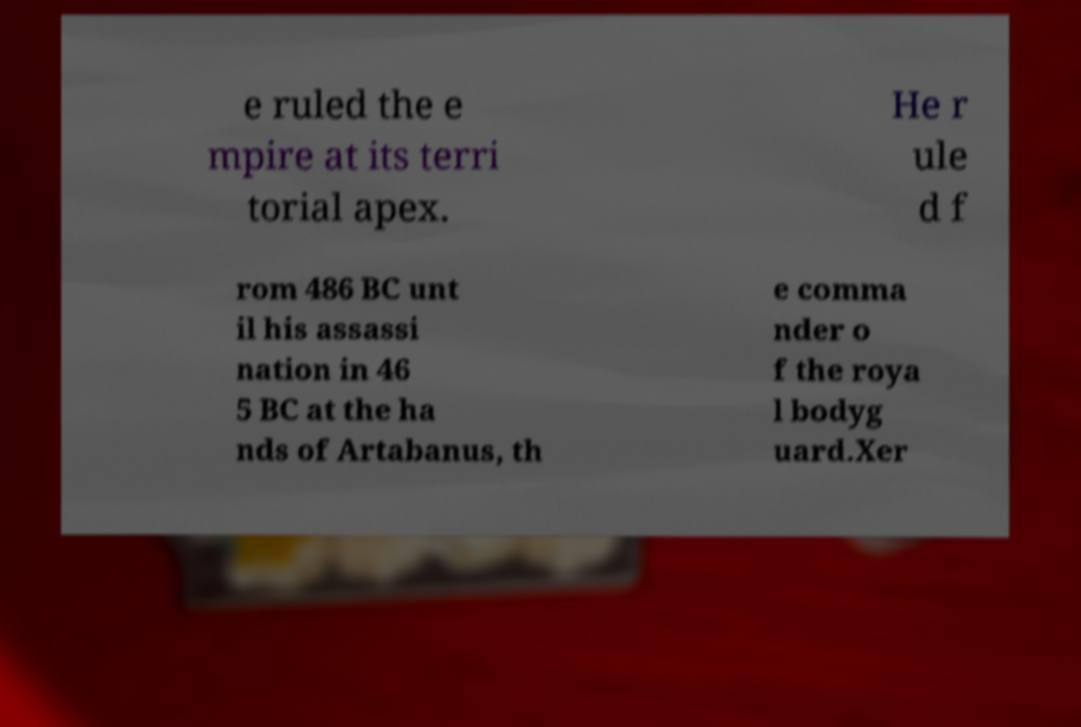I need the written content from this picture converted into text. Can you do that? e ruled the e mpire at its terri torial apex. He r ule d f rom 486 BC unt il his assassi nation in 46 5 BC at the ha nds of Artabanus, th e comma nder o f the roya l bodyg uard.Xer 